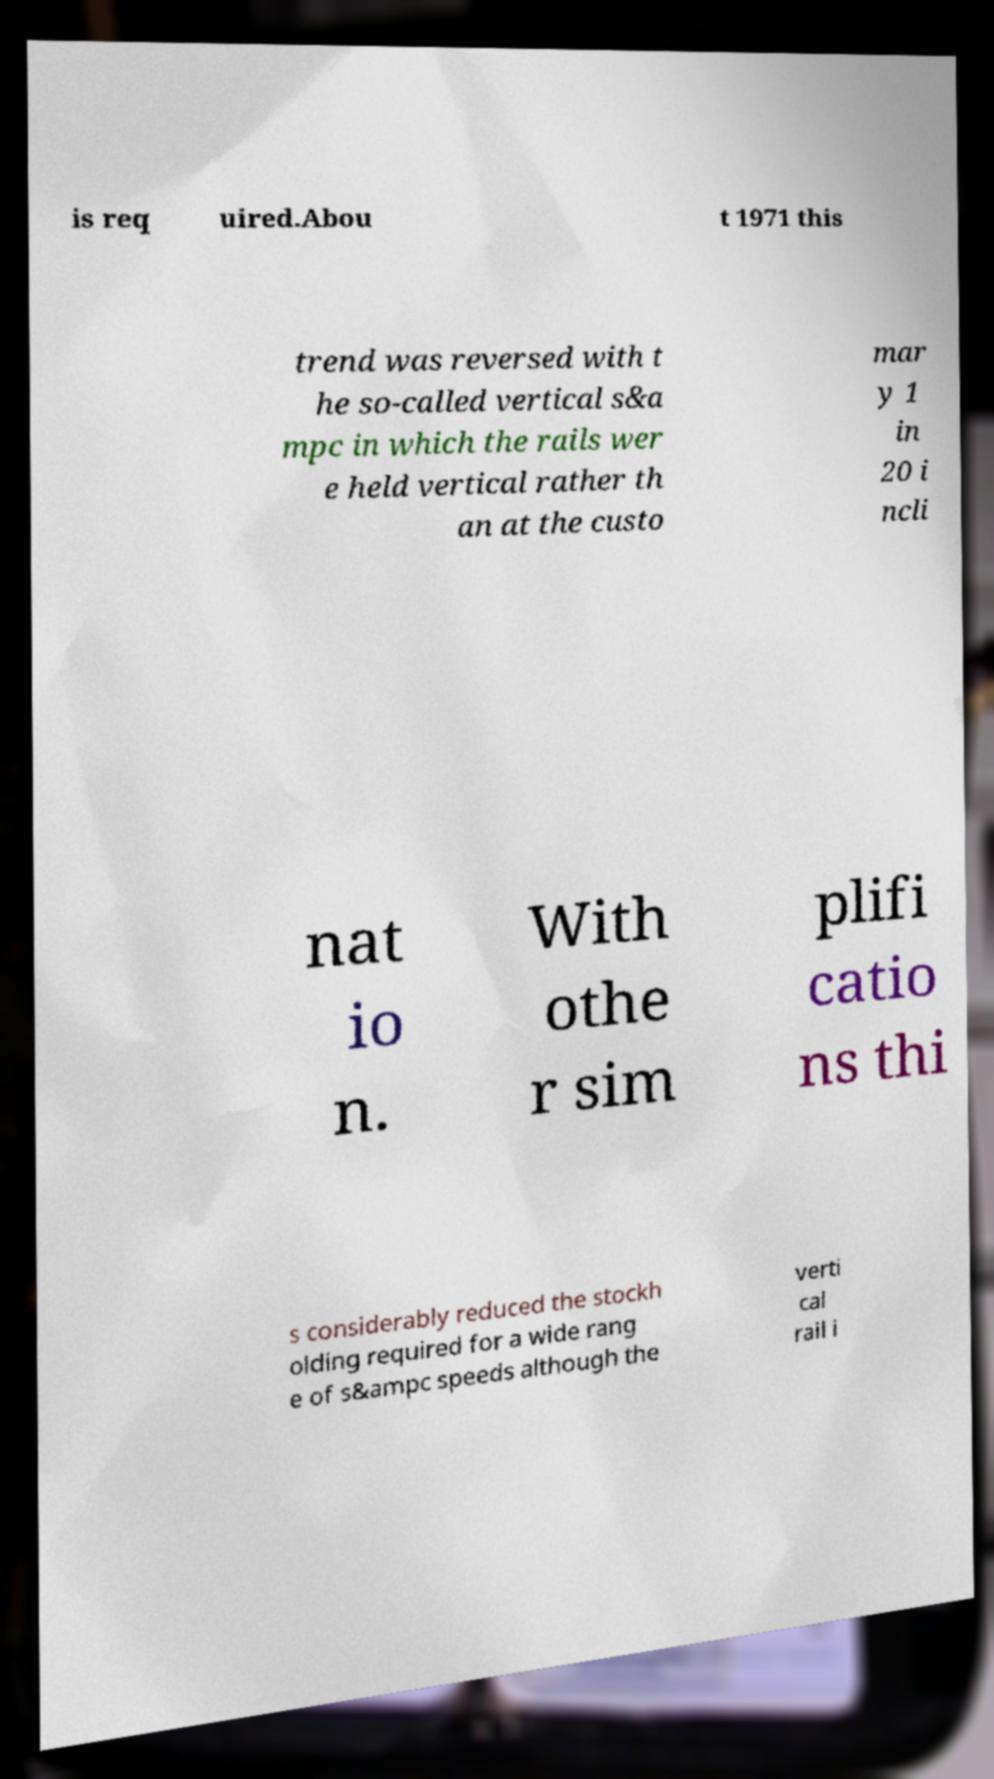Could you assist in decoding the text presented in this image and type it out clearly? is req uired.Abou t 1971 this trend was reversed with t he so-called vertical s&a mpc in which the rails wer e held vertical rather th an at the custo mar y 1 in 20 i ncli nat io n. With othe r sim plifi catio ns thi s considerably reduced the stockh olding required for a wide rang e of s&ampc speeds although the verti cal rail i 